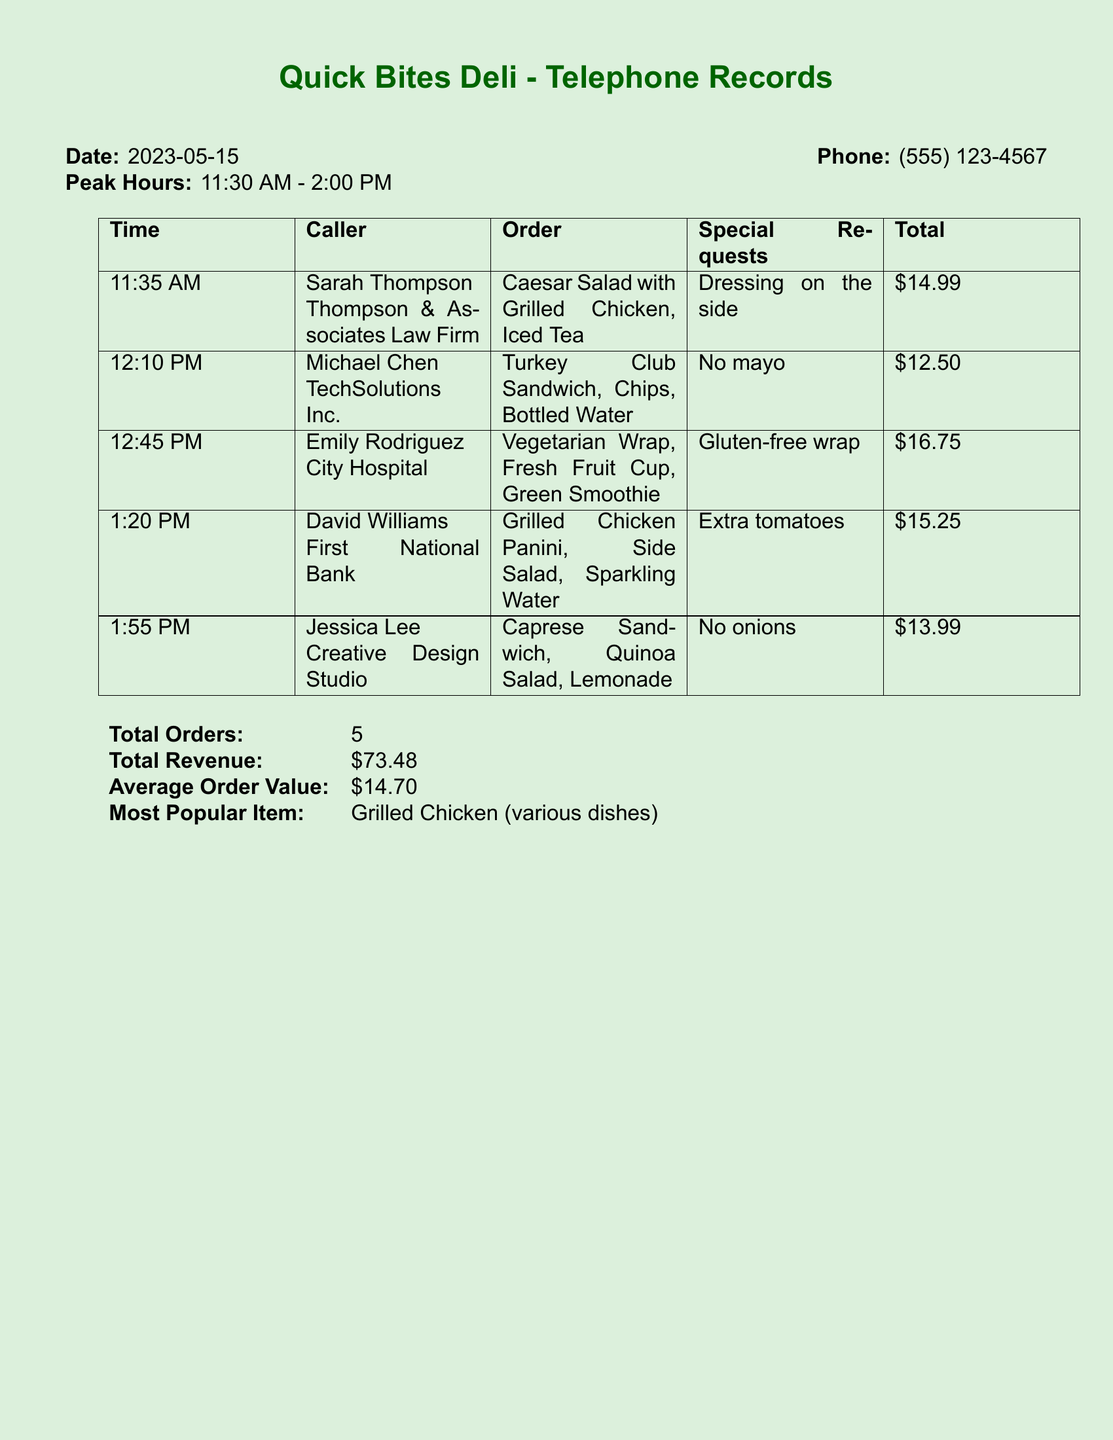What is the date of the call log? The document states the date at the beginning, which is 2023-05-15.
Answer: 2023-05-15 What is the phone number listed? The phone number is provided in the header of the document, which is (555) 123-4567.
Answer: (555) 123-4567 How many total orders were placed? The total number of orders is mentioned in the summary section of the document, which is 5.
Answer: 5 What was the most popular item ordered? The document identifies the most popular item as grilled chicken in various dishes.
Answer: Grilled Chicken (various dishes) What was Emily Rodriguez's special request? Emily Rodriguez's order special request is explicitly noted in her order, which is a gluten-free wrap.
Answer: Gluten-free wrap What was the average order value? The average order value is calculated and listed in the summary section as $14.70.
Answer: $14.70 Which company did Michael Chen call from? The caller's association is noted in the order section, which is TechSolutions Inc.
Answer: TechSolutions Inc What time did Jessica Lee place her order? The time of Jessica Lee's order is recorded in the order list as 1:55 PM.
Answer: 1:55 PM What type of drink did David Williams order? The drink ordered by David Williams is clearly documented in his order as sparkling water.
Answer: Sparkling Water 